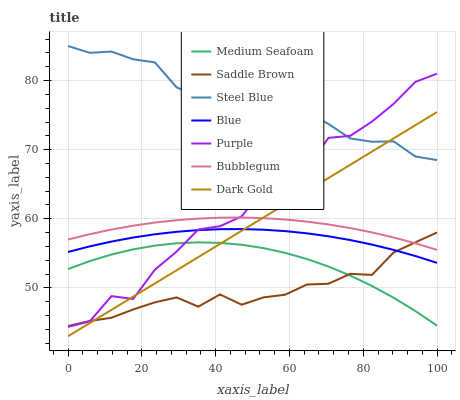Does Saddle Brown have the minimum area under the curve?
Answer yes or no. Yes. Does Steel Blue have the maximum area under the curve?
Answer yes or no. Yes. Does Dark Gold have the minimum area under the curve?
Answer yes or no. No. Does Dark Gold have the maximum area under the curve?
Answer yes or no. No. Is Dark Gold the smoothest?
Answer yes or no. Yes. Is Purple the roughest?
Answer yes or no. Yes. Is Purple the smoothest?
Answer yes or no. No. Is Dark Gold the roughest?
Answer yes or no. No. Does Dark Gold have the lowest value?
Answer yes or no. Yes. Does Purple have the lowest value?
Answer yes or no. No. Does Steel Blue have the highest value?
Answer yes or no. Yes. Does Dark Gold have the highest value?
Answer yes or no. No. Is Medium Seafoam less than Blue?
Answer yes or no. Yes. Is Blue greater than Medium Seafoam?
Answer yes or no. Yes. Does Purple intersect Medium Seafoam?
Answer yes or no. Yes. Is Purple less than Medium Seafoam?
Answer yes or no. No. Is Purple greater than Medium Seafoam?
Answer yes or no. No. Does Medium Seafoam intersect Blue?
Answer yes or no. No. 